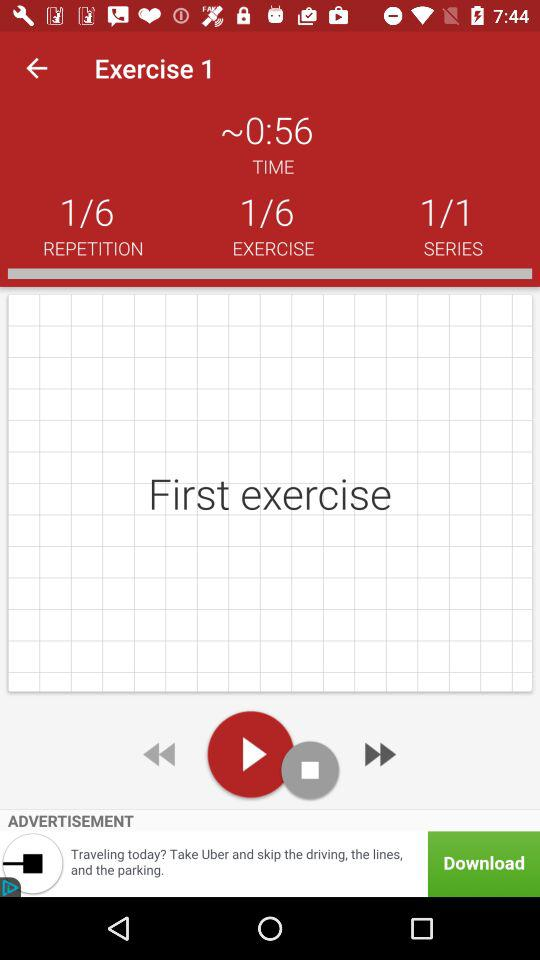On which exercise number am I? You are on exercise number 1. 